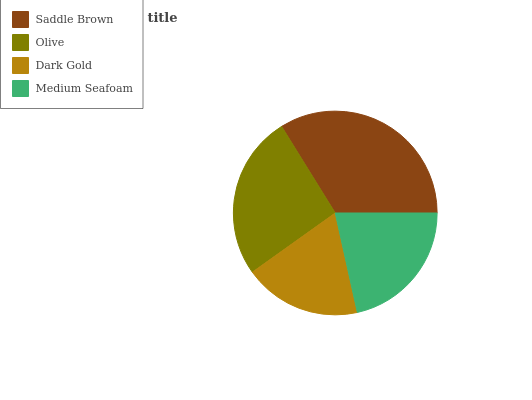Is Dark Gold the minimum?
Answer yes or no. Yes. Is Saddle Brown the maximum?
Answer yes or no. Yes. Is Olive the minimum?
Answer yes or no. No. Is Olive the maximum?
Answer yes or no. No. Is Saddle Brown greater than Olive?
Answer yes or no. Yes. Is Olive less than Saddle Brown?
Answer yes or no. Yes. Is Olive greater than Saddle Brown?
Answer yes or no. No. Is Saddle Brown less than Olive?
Answer yes or no. No. Is Olive the high median?
Answer yes or no. Yes. Is Medium Seafoam the low median?
Answer yes or no. Yes. Is Medium Seafoam the high median?
Answer yes or no. No. Is Dark Gold the low median?
Answer yes or no. No. 